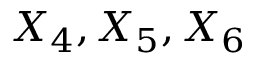Convert formula to latex. <formula><loc_0><loc_0><loc_500><loc_500>X _ { 4 } , X _ { 5 } , X _ { 6 }</formula> 